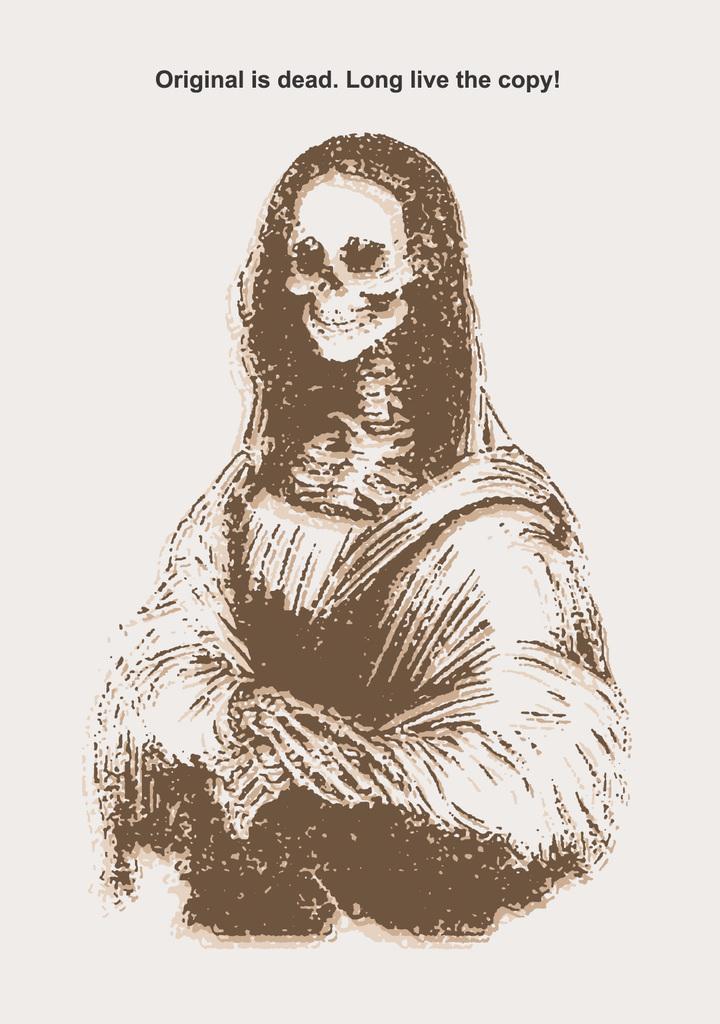Describe this image in one or two sentences. In this image we can see a picture. At the bottom there is text written on it. 